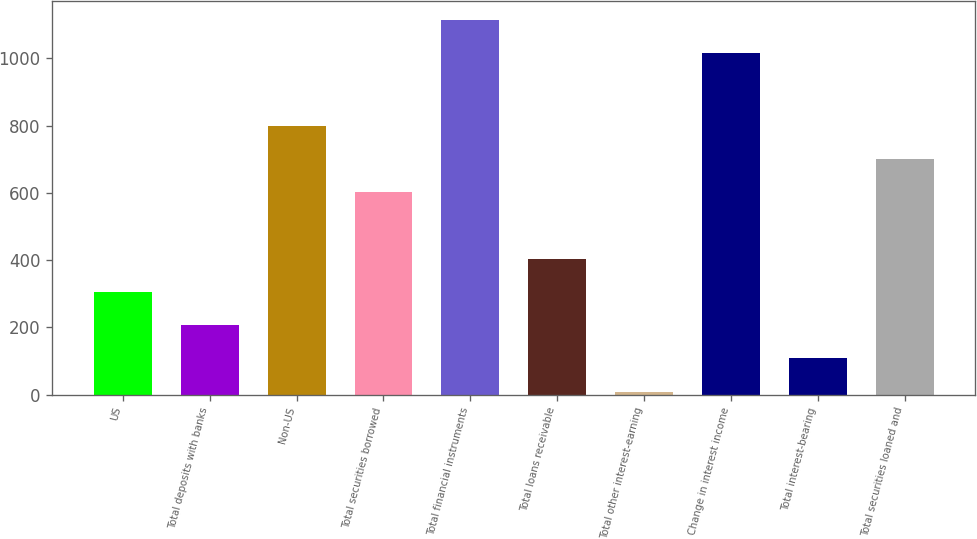<chart> <loc_0><loc_0><loc_500><loc_500><bar_chart><fcel>US<fcel>Total deposits with banks<fcel>Non-US<fcel>Total securities borrowed<fcel>Total financial instruments<fcel>Total loans receivable<fcel>Total other interest-earning<fcel>Change in interest income<fcel>Total interest-bearing<fcel>Total securities loaned and<nl><fcel>305.4<fcel>206.6<fcel>799.4<fcel>601.8<fcel>1114.6<fcel>404.2<fcel>9<fcel>1015.8<fcel>107.8<fcel>700.6<nl></chart> 